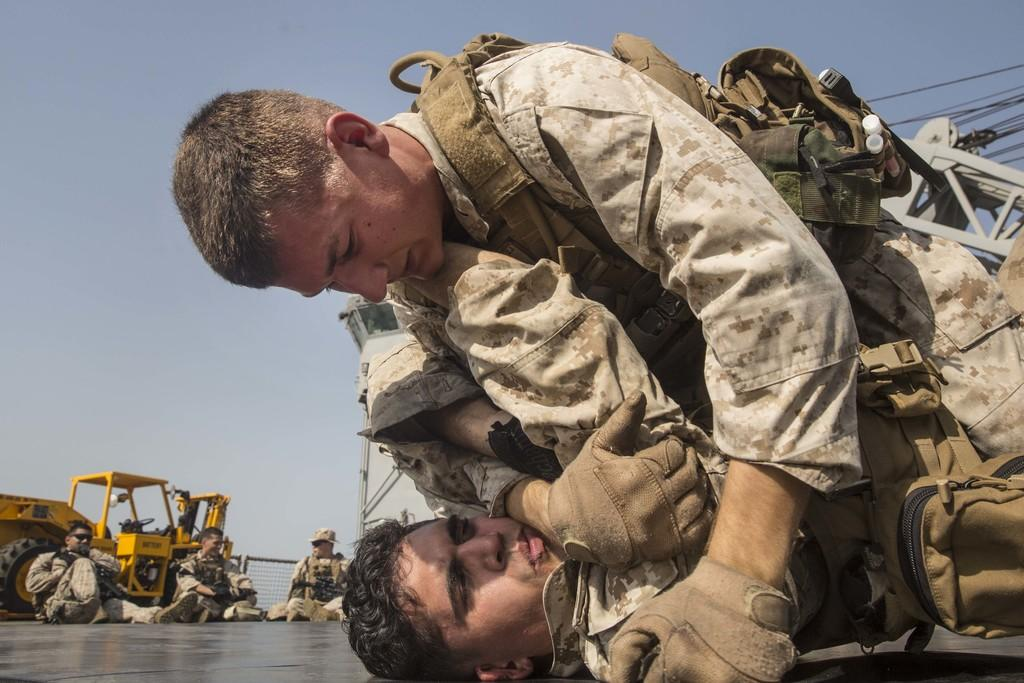How many people are present in the image? There are five persons in the image. What is the interaction between two of the persons? One person is lying on another person. What type of object can be seen in the image? There is a vehicle in the image. What architectural feature is present in the image? There is a fence in the image. What are the thin, long, and flexible objects in the image? There are cables in the image. What is visible in the background of the image? The sky is visible in the background of the image. What type of jam is being spread on the geese in the image? There are no geese or jam present in the image. What time is indicated by the clock in the image? There is no clock present in the image. 